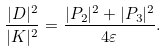<formula> <loc_0><loc_0><loc_500><loc_500>\frac { | D | ^ { 2 } } { | K | ^ { 2 } } = \frac { | P _ { 2 } | ^ { 2 } + | P _ { 3 } | ^ { 2 } } { 4 \varepsilon } .</formula> 